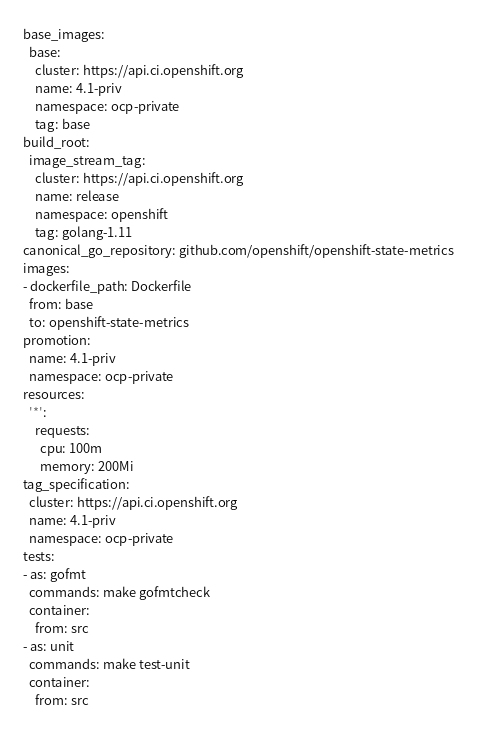<code> <loc_0><loc_0><loc_500><loc_500><_YAML_>base_images:
  base:
    cluster: https://api.ci.openshift.org
    name: 4.1-priv
    namespace: ocp-private
    tag: base
build_root:
  image_stream_tag:
    cluster: https://api.ci.openshift.org
    name: release
    namespace: openshift
    tag: golang-1.11
canonical_go_repository: github.com/openshift/openshift-state-metrics
images:
- dockerfile_path: Dockerfile
  from: base
  to: openshift-state-metrics
promotion:
  name: 4.1-priv
  namespace: ocp-private
resources:
  '*':
    requests:
      cpu: 100m
      memory: 200Mi
tag_specification:
  cluster: https://api.ci.openshift.org
  name: 4.1-priv
  namespace: ocp-private
tests:
- as: gofmt
  commands: make gofmtcheck
  container:
    from: src
- as: unit
  commands: make test-unit
  container:
    from: src
</code> 